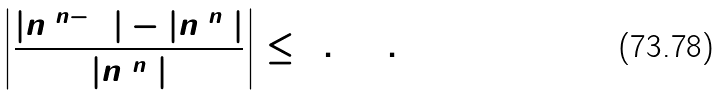<formula> <loc_0><loc_0><loc_500><loc_500>\left | \frac { | n ^ { ( n - 1 ) } | - | n ^ { ( n ) } | } { | n ^ { ( n ) } | } \right | \leq 0 . 0 0 1 .</formula> 